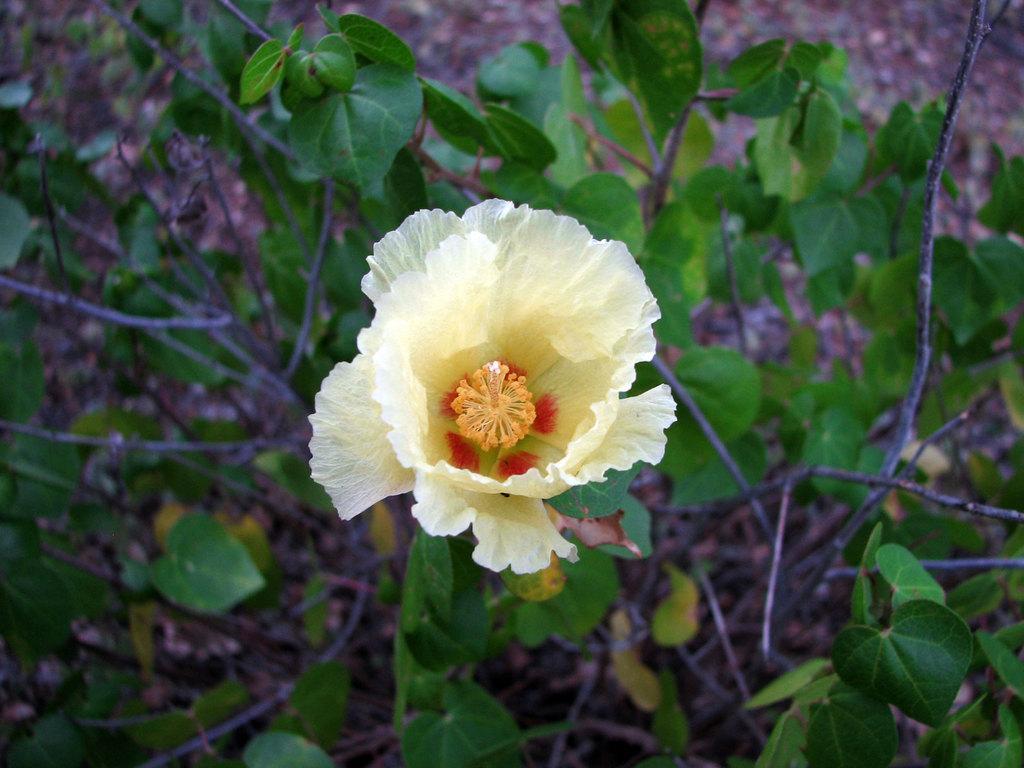In one or two sentences, can you explain what this image depicts? In this picture we can see a flower, plants and in the background it is blurry. 